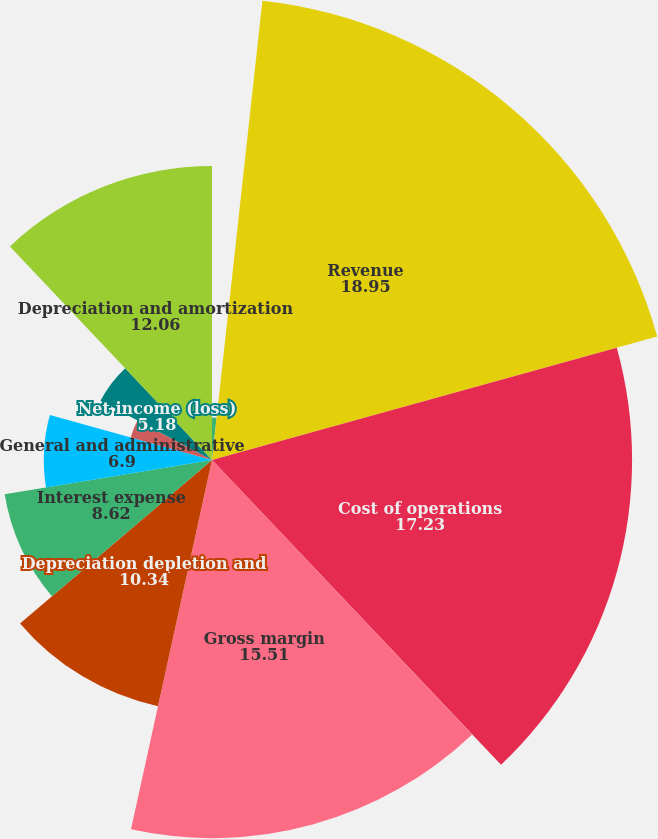Convert chart to OTSL. <chart><loc_0><loc_0><loc_500><loc_500><pie_chart><fcel>(AMOUNTS IN THOUSANDS)<fcel>Revenue<fcel>Cost of operations<fcel>Gross margin<fcel>Depreciation depletion and<fcel>Interest expense<fcel>General and administrative<fcel>Other (income) expense net<fcel>Net income (loss)<fcel>Depreciation and amortization<nl><fcel>1.74%<fcel>18.95%<fcel>17.23%<fcel>15.51%<fcel>10.34%<fcel>8.62%<fcel>6.9%<fcel>3.46%<fcel>5.18%<fcel>12.06%<nl></chart> 